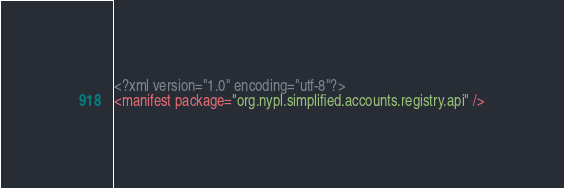Convert code to text. <code><loc_0><loc_0><loc_500><loc_500><_XML_><?xml version="1.0" encoding="utf-8"?>
<manifest package="org.nypl.simplified.accounts.registry.api" />
</code> 